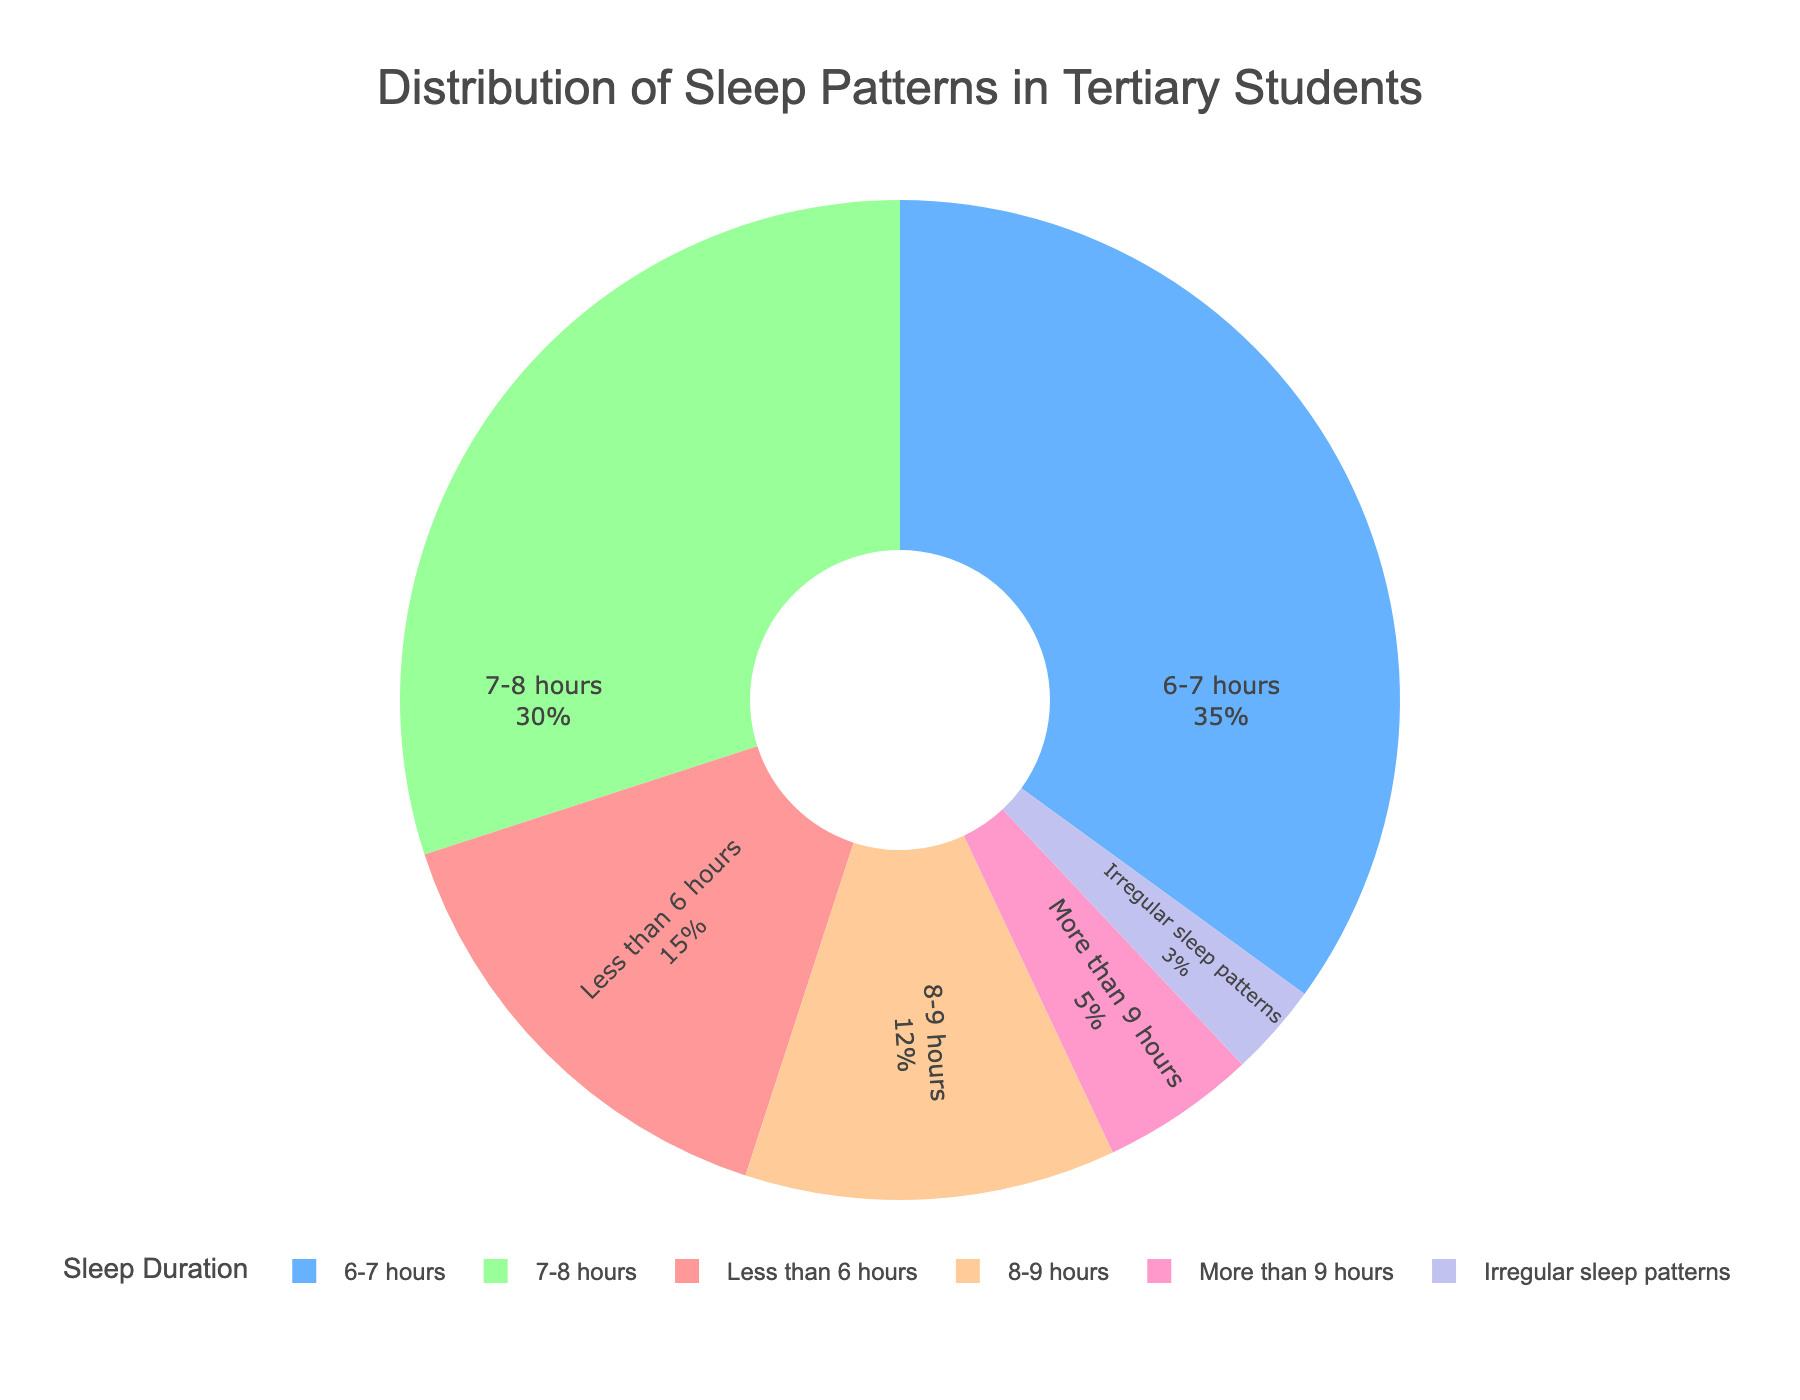What percentage of students sleep 6-7 hours? Refer to the pie chart segment labeled '6-7 hours'. The label shows the percentage directly.
Answer: 35% Which sleep category has the smallest percentage of students? Identify the smallest section of the pie chart and read its label.
Answer: Irregular sleep patterns What is the combined percentage of students sleeping less than 6 hours and those with irregular sleep patterns? Add the percentages for 'Less than 6 hours' and 'Irregular sleep patterns': 15% + 3% = 18%.
Answer: 18% How does the percentage of students sleeping 7-8 hours compare to those sleeping more than 9 hours? Compare the percentages given in the labels: 30% (7-8 hours) is larger than 5% (More than 9 hours).
Answer: 7-8 hours is significantly more What is the proportion of students getting at least 8 hours of sleep (8-9 hours plus more than 9 hours)? Add the percentages of '8-9 hours' and 'More than 9 hours': 12% + 5% = 17%.
Answer: 17% If you were to combine all students who sleep either less than 6 hours or between 6-7 hours, what would be their total percentage? Add the percentages of 'Less than 6 hours' and '6-7 hours': 15% + 35% = 50%.
Answer: 50% Identify the color used for students with irregular sleep patterns. Look for the segment labeled 'Irregular sleep patterns' and note its color.
Answer: Light purple What percentage of students sleep between 6-8 hours? Add the percentages for '6-7 hours' and '7-8 hours': 35% + 30% = 65%.
Answer: 65% Is the proportion of students sleeping 7-8 hours greater or less than those sleeping 8-9 hours? Compare the percentages: 30% (7-8 hours) is greater than 12% (8-9 hours).
Answer: Greater Among the given sleep categories, which two have the closest percentages? Compare the percentage values of all categories and find the closest ones: '7-8 hours' (30%) and '6-7 hours' (35%) are the closest.
Answer: 7-8 hours and 6-7 hours 